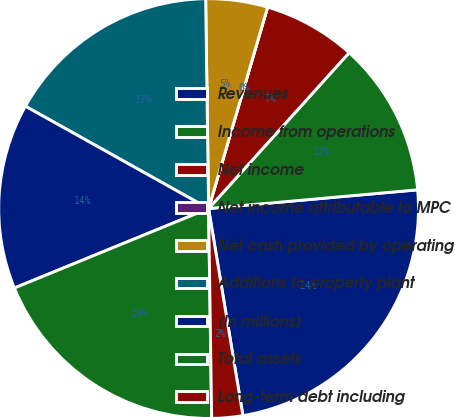Convert chart to OTSL. <chart><loc_0><loc_0><loc_500><loc_500><pie_chart><fcel>Revenues<fcel>Income from operations<fcel>Net income<fcel>Net income attributable to MPC<fcel>Net cash provided by operating<fcel>Additions to property plant<fcel>(In millions)<fcel>Total assets<fcel>Long-term debt including<nl><fcel>23.81%<fcel>11.9%<fcel>7.14%<fcel>0.0%<fcel>4.76%<fcel>16.67%<fcel>14.29%<fcel>19.05%<fcel>2.38%<nl></chart> 